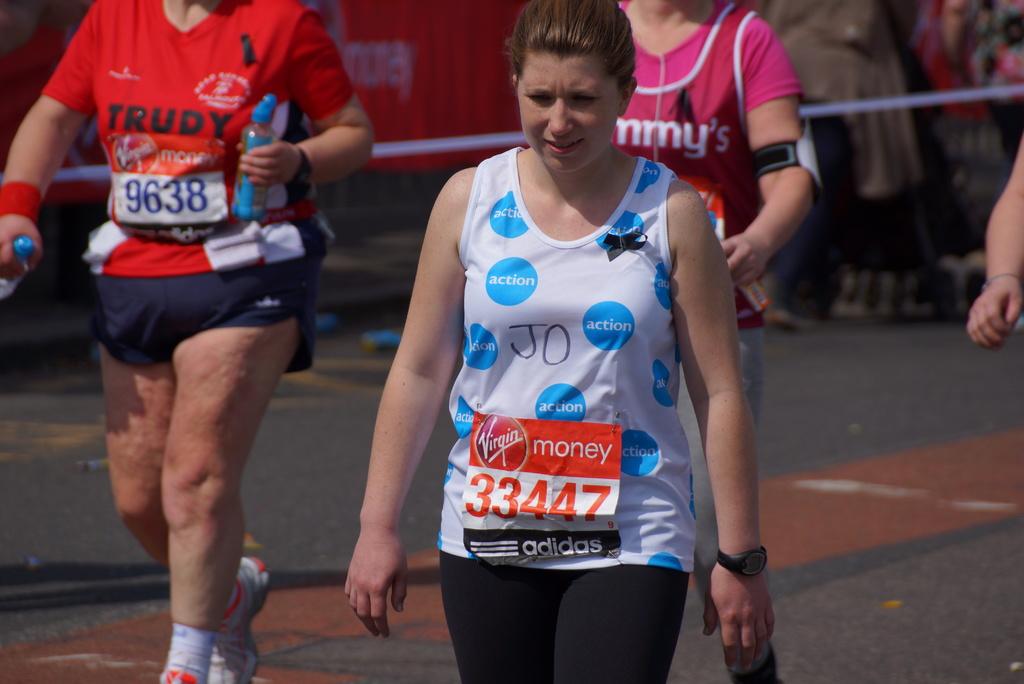What number is the competitor in white?
Your answer should be very brief. 33447. What is the name of the competitor in red?
Ensure brevity in your answer.  Trudy. 